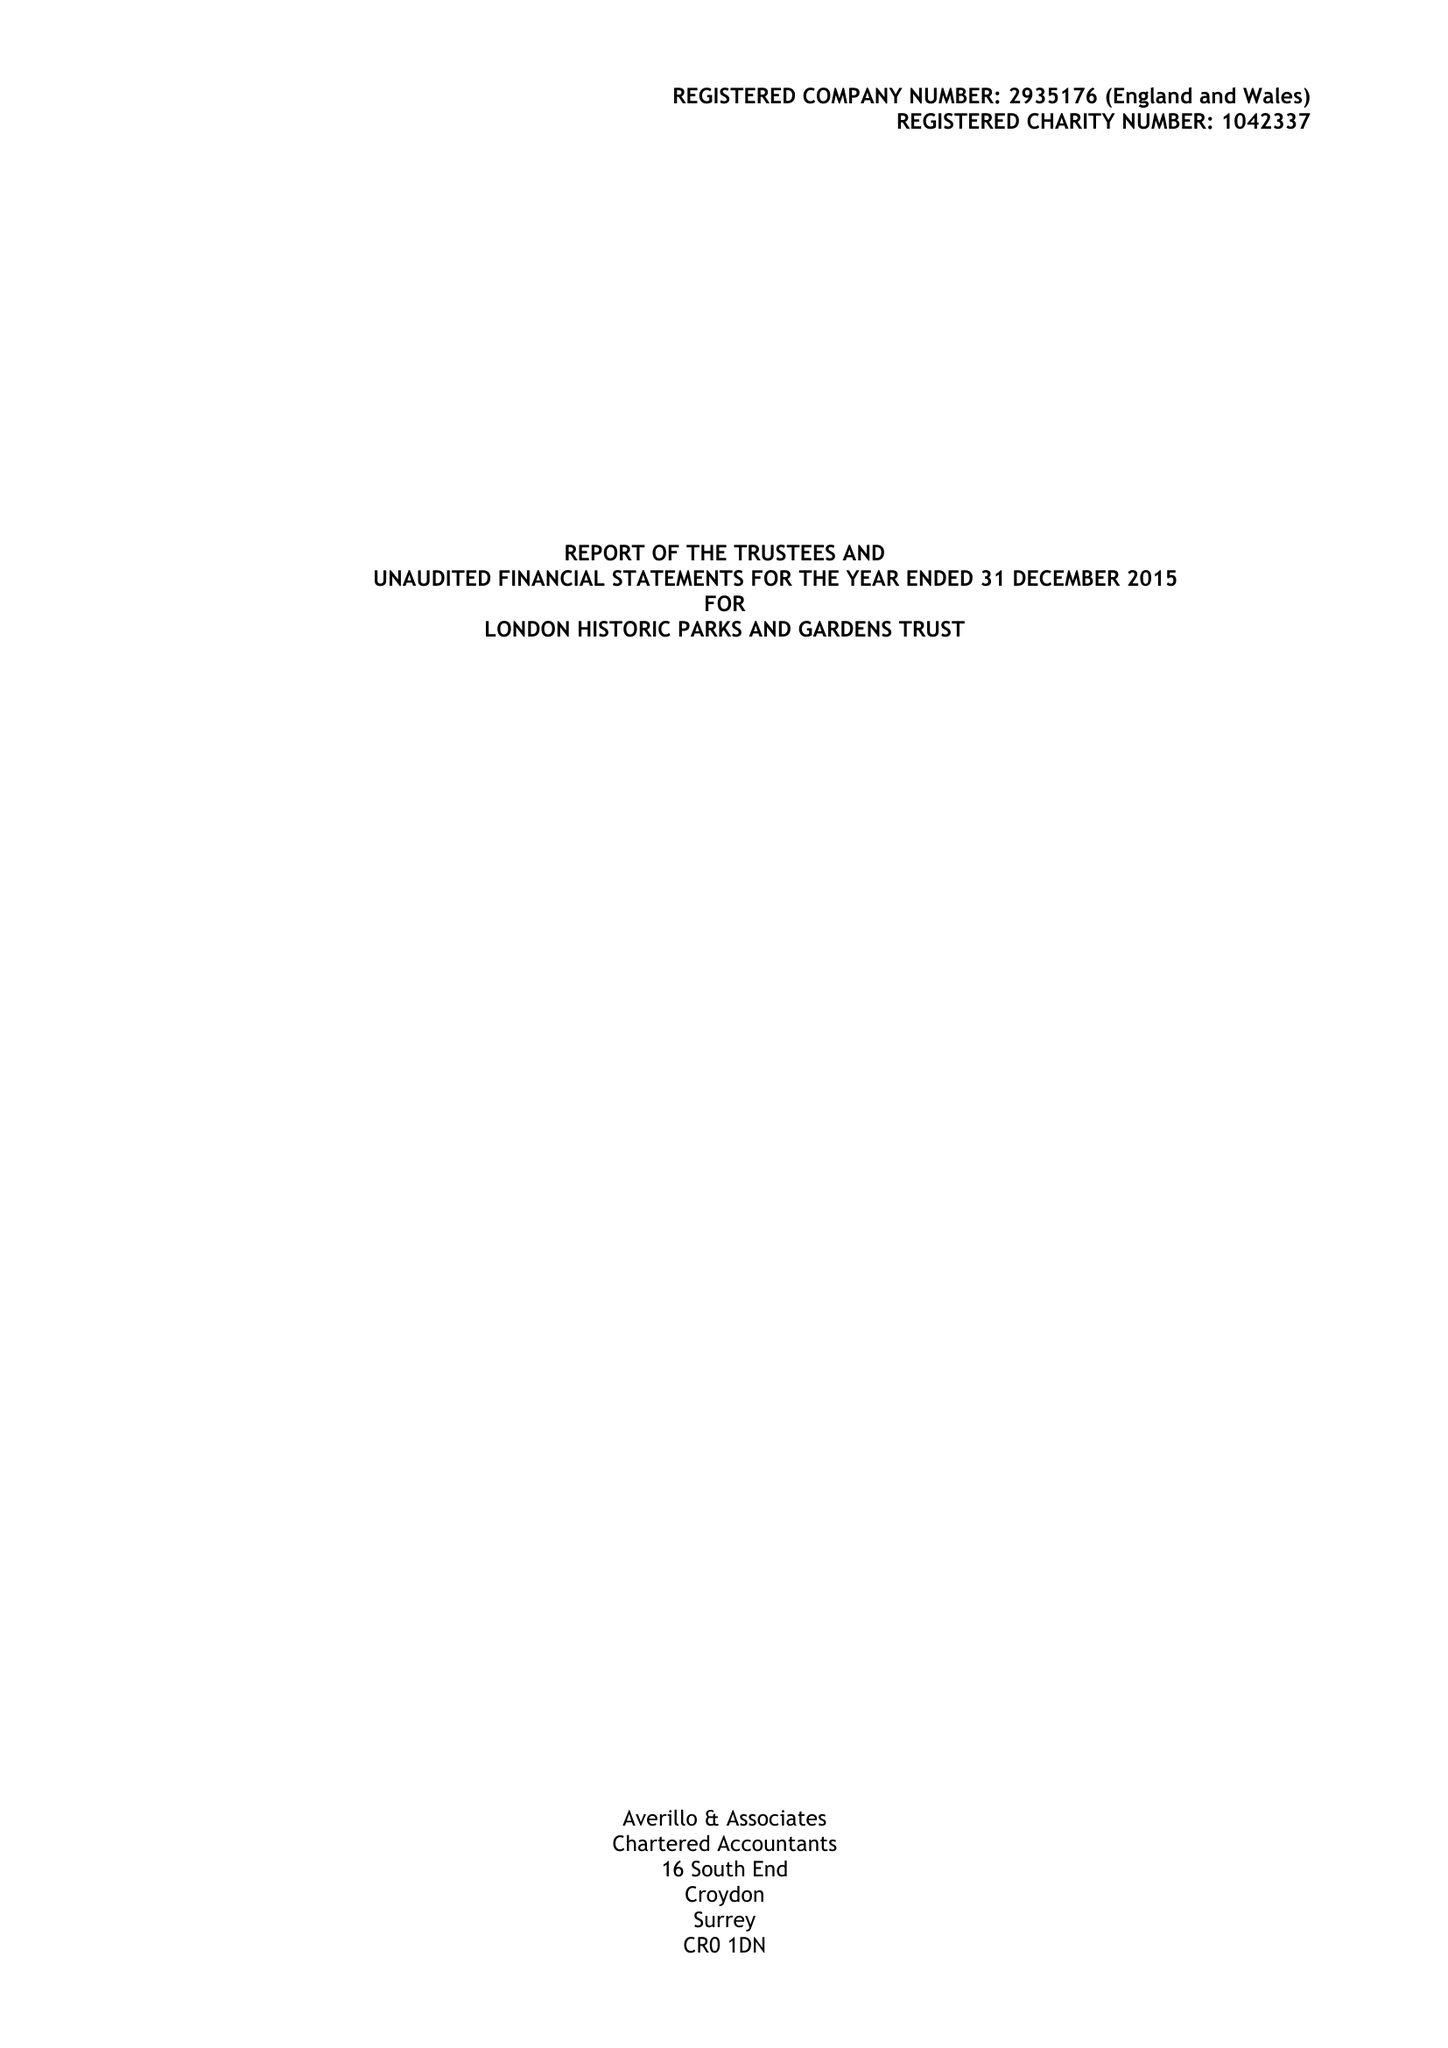What is the value for the charity_name?
Answer the question using a single word or phrase. London Historic Parks and Gardens Trust 